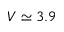Convert formula to latex. <formula><loc_0><loc_0><loc_500><loc_500>V \simeq 3 . 9</formula> 